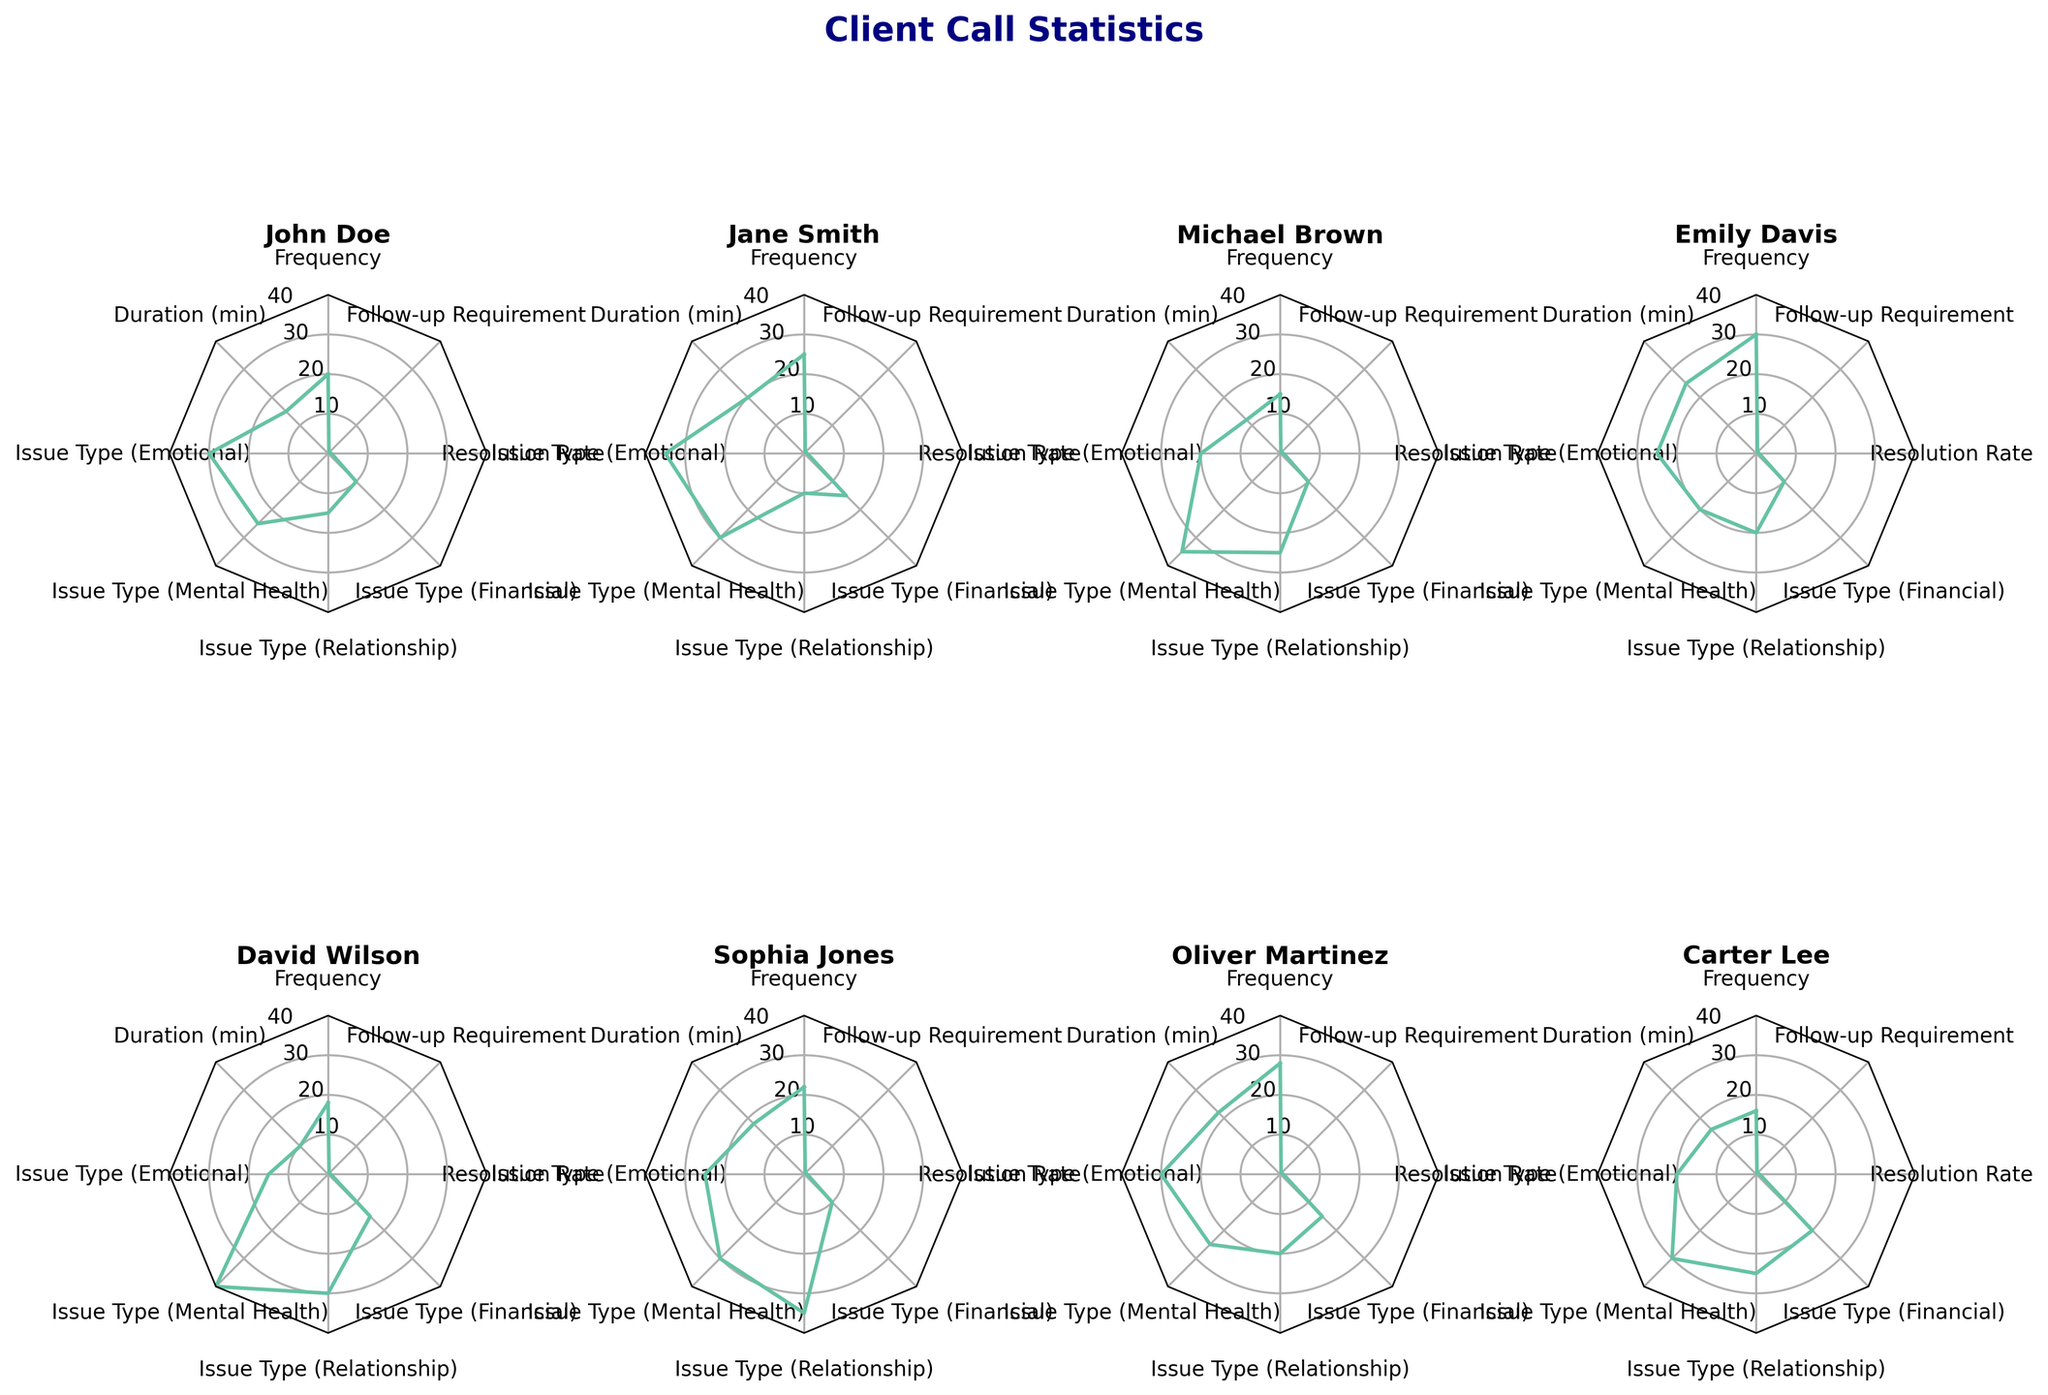What is the title of the radar chart? The title of the radar chart is located at the top of the figure, often in a larger and bold font to make it noticeable.
Answer: Client Call Statistics Which client has the highest call frequency? By examining the radar sections corresponding to 'Frequency' in each subplot, identify the one with the highest value.
Answer: Emily Davis What is the average follow-up requirement percentage for Oliver Martinez and Sophia Jones? Add the follow-up requirement percentages for Oliver Martinez (0.33) and Sophia Jones (0.38), and then divide by 2 to find the average. (0.33 + 0.38) / 2 = 0.355
Answer: 0.355 Who has the lowest duration on call in minutes? Find the subplot representing the client with the bar closest to the center for 'Duration (min)'.
Answer: David Wilson Compare the resolution rates of John Doe and Carter Lee. Who has a higher resolution rate? Look at the resolution rate values for John Doe (0.85) and Carter Lee (0.88). Compare these two values.
Answer: Carter Lee Which client has the highest percentage for Mental Health issue type? Identify the radar section labeled 'Issue Type (Mental Health)' and find the plot with the highest value in that section.
Answer: David Wilson Is there any client with a financial issue type percentage higher than 20%? Examine the 'Issue Type (Financial)' section across all clients to find any value exceeding 20%.
Answer: Carter Lee Which client has the most balanced distribution across all categories? Identify the client whose radar plot is most circular and evenly spread across all categories.
Answer: Carter Lee What is the range of resolution rates among all clients? Find the minimum and maximum values for the 'Resolution Rate' across all clients and calculate the difference. Maximum is 0.90 (Michael Brown) and the minimum is 0.70 (David Wilson). 0.90 - 0.70 = 0.20
Answer: 0.20 How does Jane Smith's call duration compare to the average duration of all clients? Calculate the mean call duration across all clients, then compare Jane Smith’s call duration (20 mins) to this average. (15 + 20 + 12 + 25 + 10 + 18 + 22 + 16) / 8 = 17.25. Jane Smith's duration is higher.
Answer: Higher 